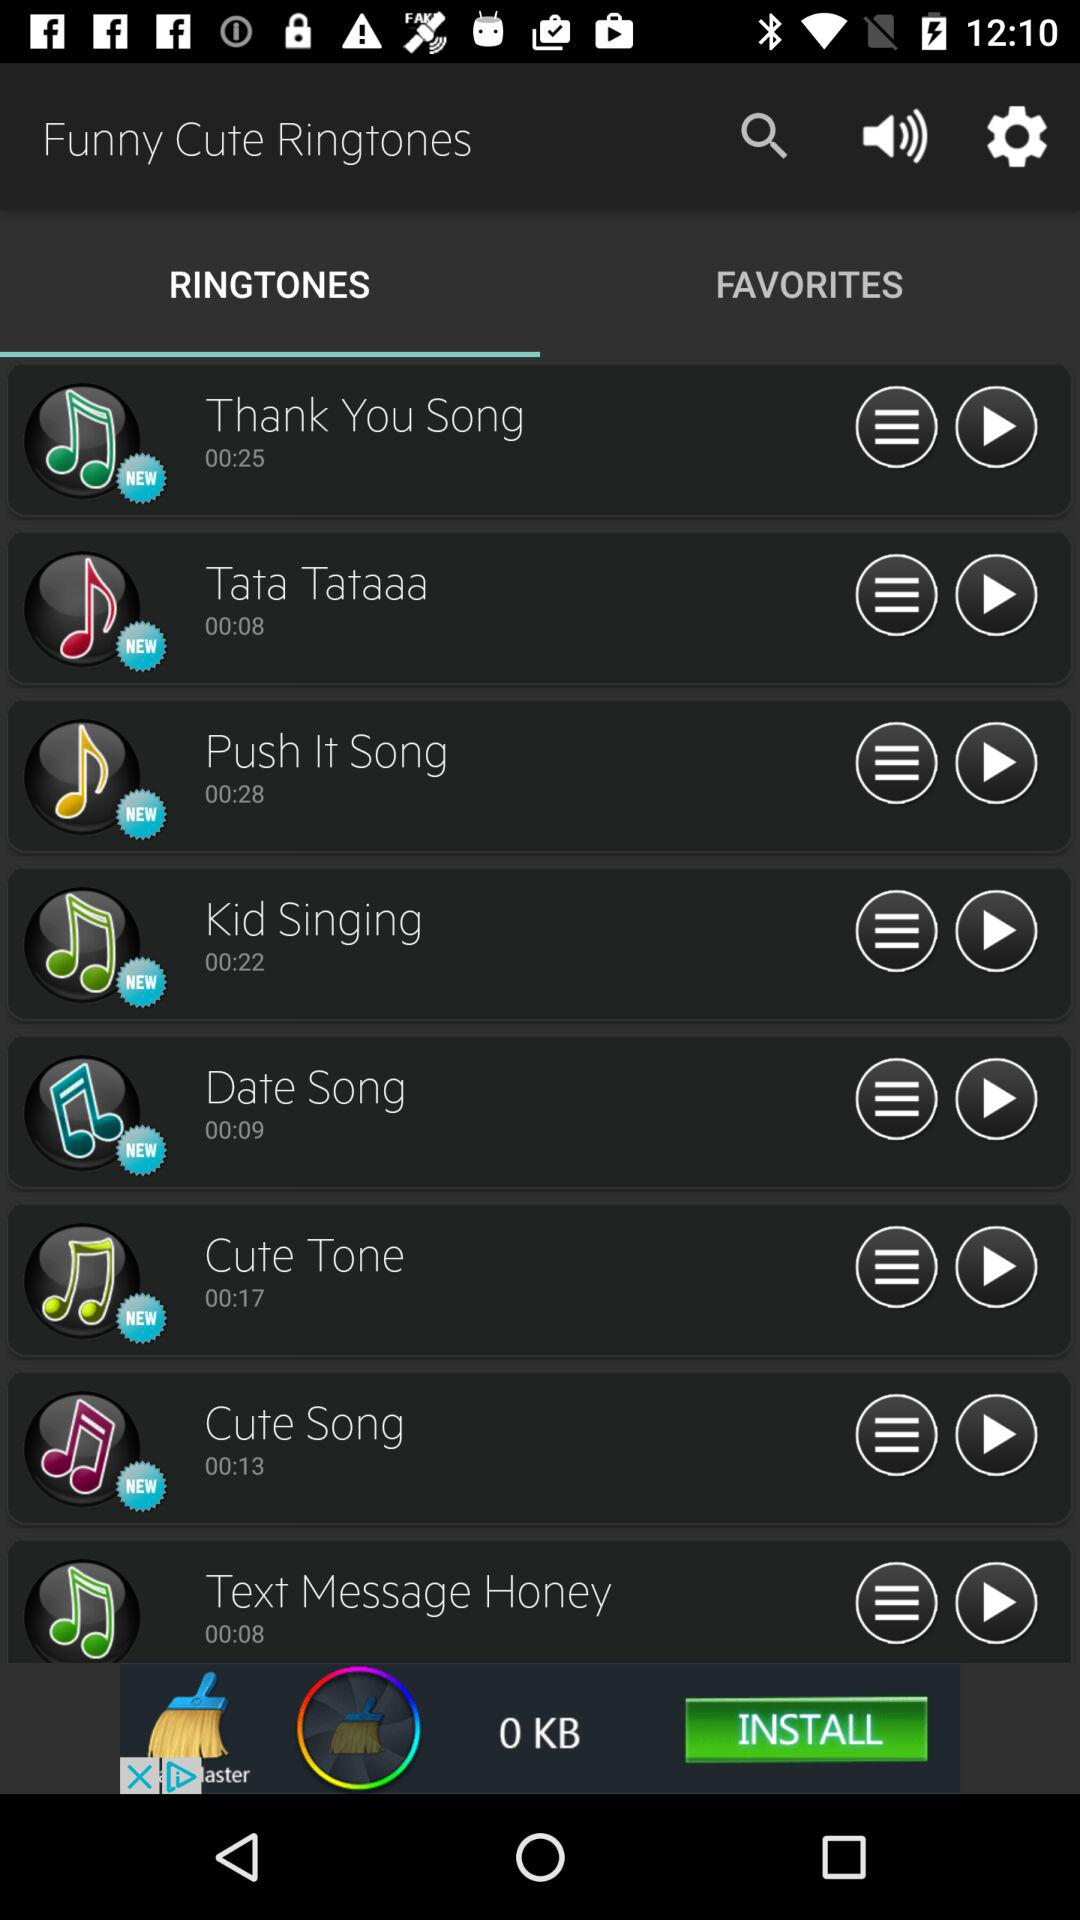Which tab am I on? You are on the "RINGTONES" tab. 